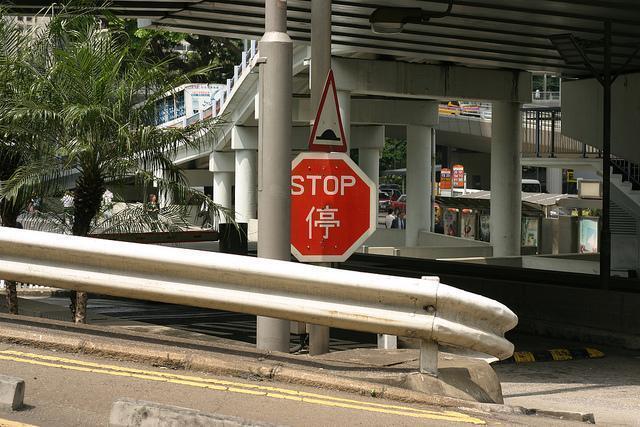What device is used to ensure people stop here?
Select the accurate answer and provide explanation: 'Answer: answer
Rationale: rationale.'
Options: Camera, road spikes, speedbump, gate. Answer: speedbump.
Rationale: The black and yellow striped obstacle on the road is a speedbump. 